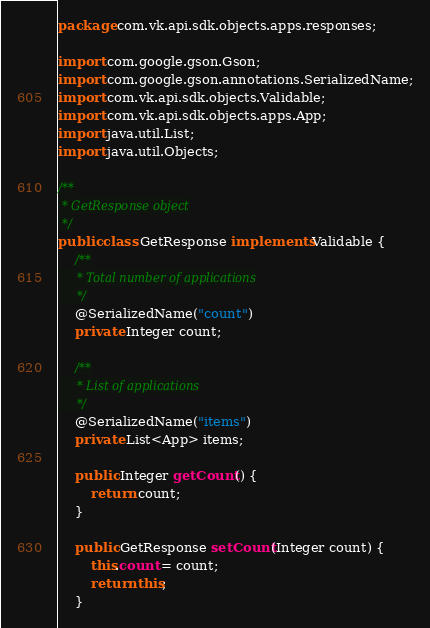Convert code to text. <code><loc_0><loc_0><loc_500><loc_500><_Java_>package com.vk.api.sdk.objects.apps.responses;

import com.google.gson.Gson;
import com.google.gson.annotations.SerializedName;
import com.vk.api.sdk.objects.Validable;
import com.vk.api.sdk.objects.apps.App;
import java.util.List;
import java.util.Objects;

/**
 * GetResponse object
 */
public class GetResponse implements Validable {
    /**
     * Total number of applications
     */
    @SerializedName("count")
    private Integer count;

    /**
     * List of applications
     */
    @SerializedName("items")
    private List<App> items;

    public Integer getCount() {
        return count;
    }

    public GetResponse setCount(Integer count) {
        this.count = count;
        return this;
    }
</code> 